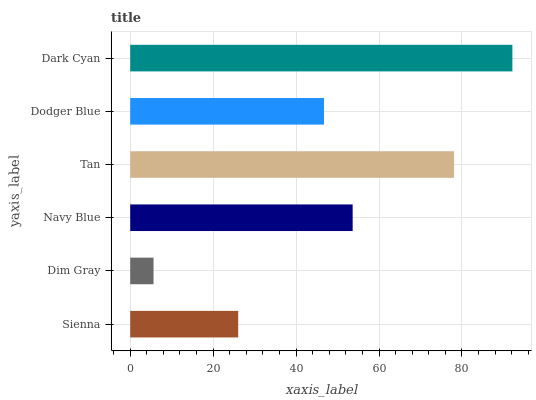Is Dim Gray the minimum?
Answer yes or no. Yes. Is Dark Cyan the maximum?
Answer yes or no. Yes. Is Navy Blue the minimum?
Answer yes or no. No. Is Navy Blue the maximum?
Answer yes or no. No. Is Navy Blue greater than Dim Gray?
Answer yes or no. Yes. Is Dim Gray less than Navy Blue?
Answer yes or no. Yes. Is Dim Gray greater than Navy Blue?
Answer yes or no. No. Is Navy Blue less than Dim Gray?
Answer yes or no. No. Is Navy Blue the high median?
Answer yes or no. Yes. Is Dodger Blue the low median?
Answer yes or no. Yes. Is Sienna the high median?
Answer yes or no. No. Is Sienna the low median?
Answer yes or no. No. 